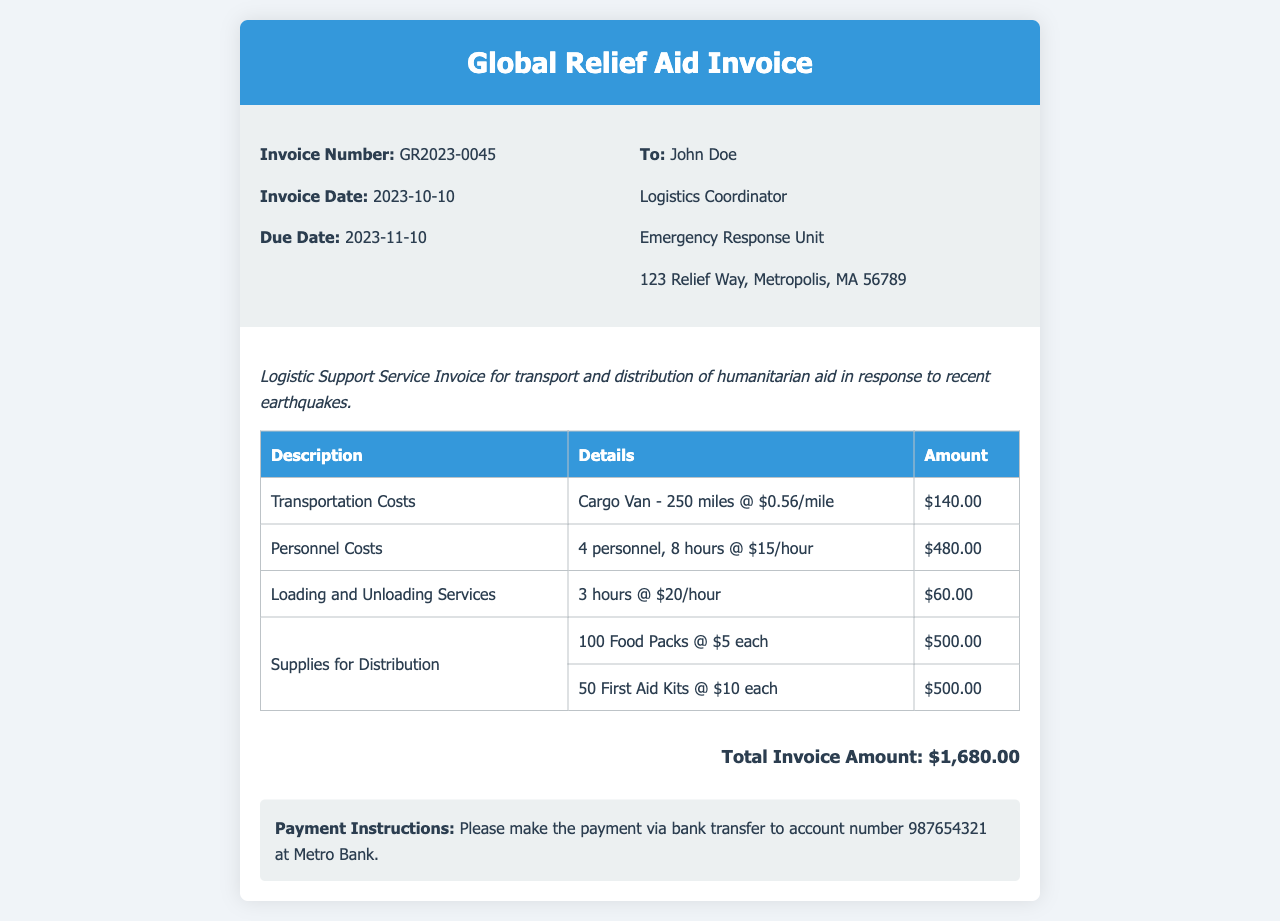What is the invoice number? The invoice number is provided in the header section of the document.
Answer: GR2023-0045 What is the total invoice amount? The total invoice amount is calculated at the bottom of the invoice.
Answer: $1,680.00 How many personnel were involved? The number of personnel is specified in the personnel costs section of the invoice.
Answer: 4 What is the mileage for the transport? The mileage for the transport is indicated in the transportation costs section.
Answer: 250 miles What is the payment due date? The payment due date is listed in the invoice details section.
Answer: 2023-11-10 How much were the supplies for distribution in total? The total amount for the supplies is calculated by adding the cost of food packs and first aid kits.
Answer: $1,000.00 What is the rate per mile for transportation? The rate for transportation per mile is mentioned in the transportation costs section.
Answer: $0.56/mile How many hours were billed for loading and unloading services? The number of hours billed for this service is specified in the invoice body.
Answer: 3 hours What are the payment instructions? The payment instructions are provided towards the end of the invoice.
Answer: Please make the payment via bank transfer to account number 987654321 at Metro Bank 